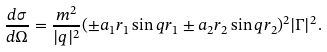<formula> <loc_0><loc_0><loc_500><loc_500>\frac { d \sigma } { d \Omega } = \frac { m ^ { 2 } } { | q | ^ { 2 } } ( \pm a _ { 1 } r _ { 1 } \sin { q r _ { 1 } } \pm a _ { 2 } r _ { 2 } \sin { q r _ { 2 } } ) ^ { 2 } | \Gamma | ^ { 2 } .</formula> 